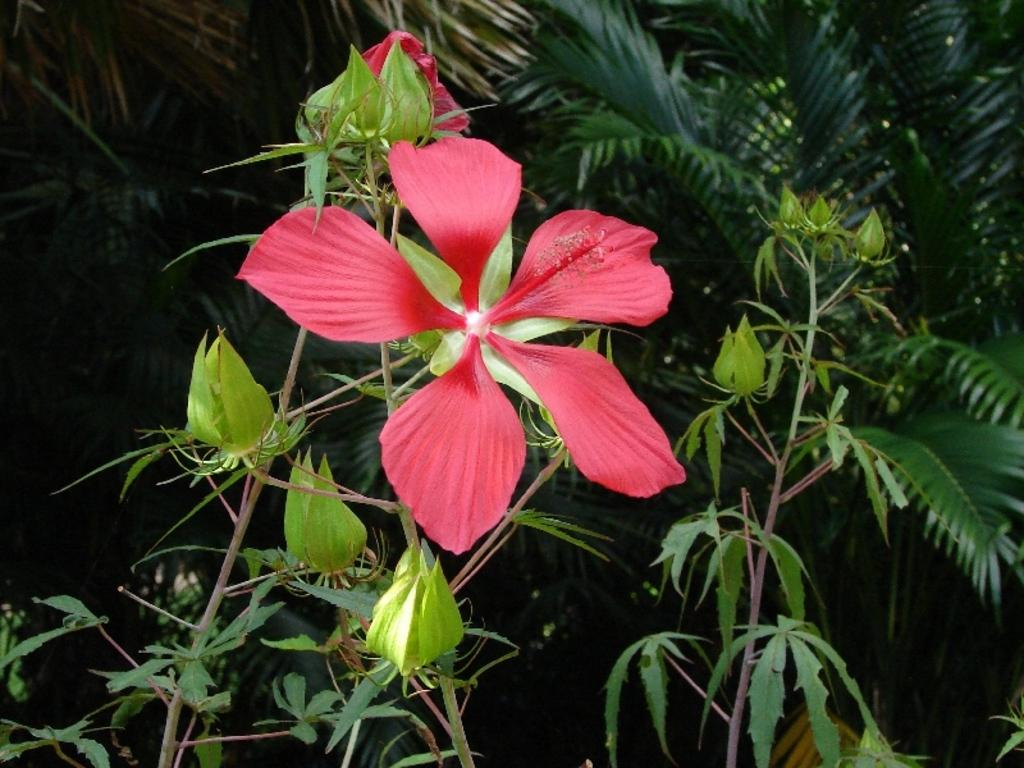What types of vegetation can be seen in the image? There are many plants and flowers in the image. Can you describe the growth stage of the plants in the image? There are buds on the plants in the image. What type of appliance can be seen in the image? There is no appliance present in the image; it features plants and flowers. How do the giants interact with the plants in the image? There are no giants present in the image, so their interaction with the plants cannot be observed. 